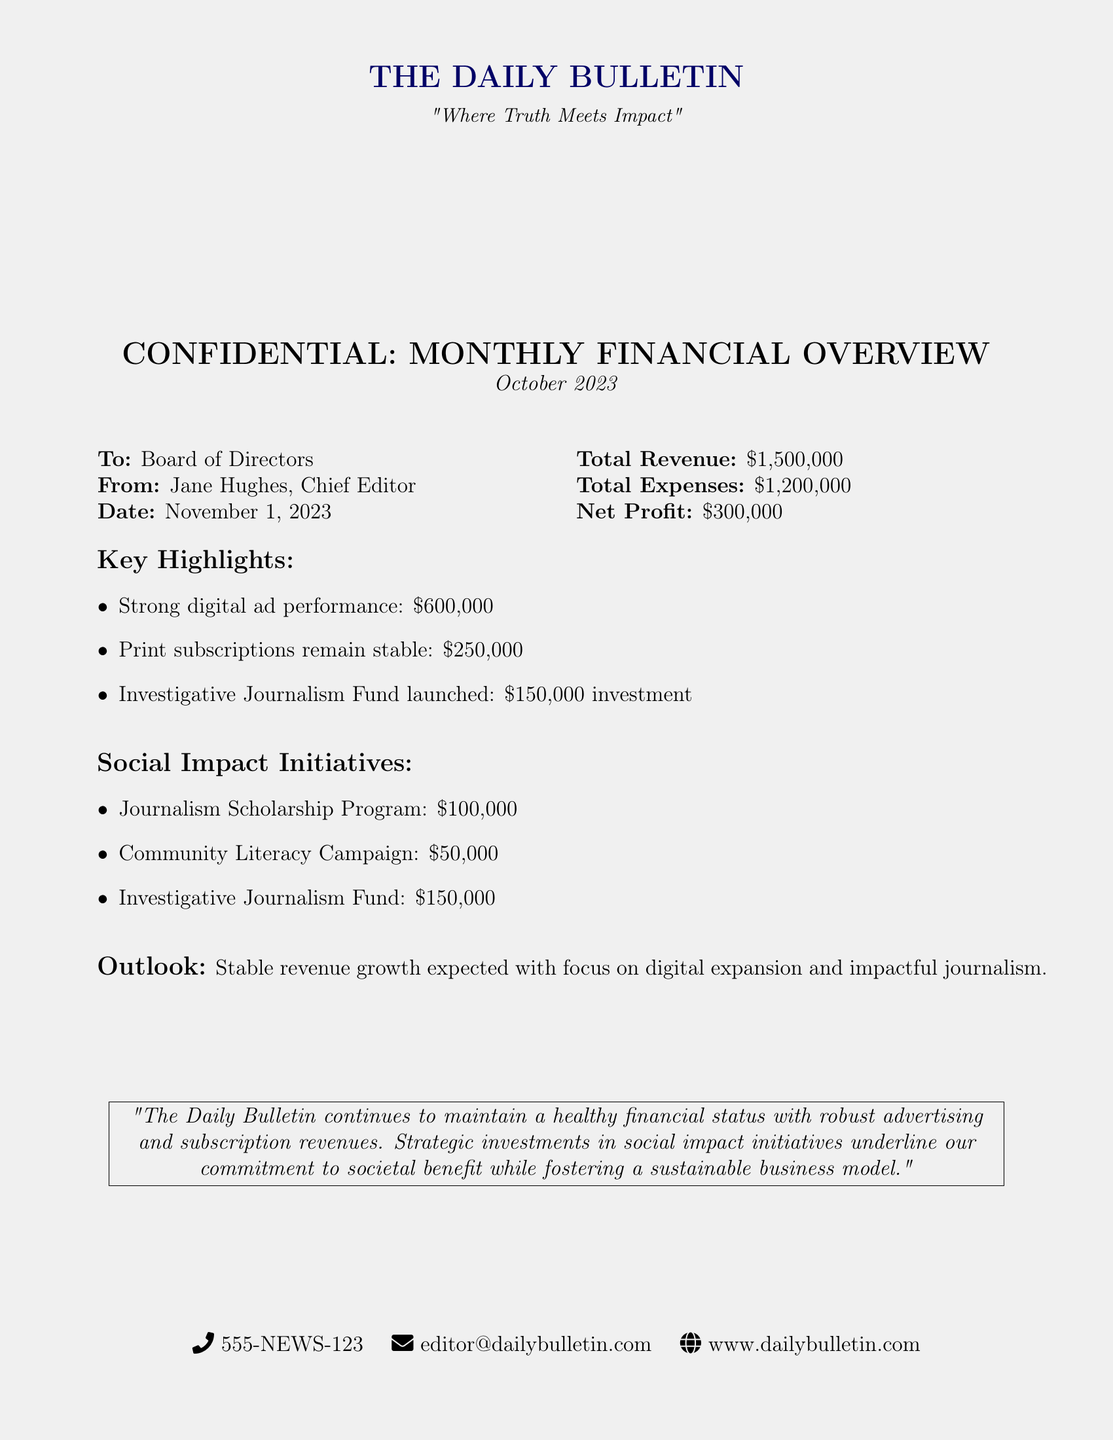what is the total revenue? The total revenue is explicitly stated as $1,500,000 in the document.
Answer: $1,500,000 who is the Chief Editor? The Chief Editor is identified in the document as Jane Hughes.
Answer: Jane Hughes what is the net profit? The net profit is calculated by subtracting total expenses from total revenue, which is $300,000.
Answer: $300,000 how much was invested in the Investigative Journalism Fund? The investment amount for the Investigative Journalism Fund is listed as $150,000.
Answer: $150,000 what is the total amount allocated for social impact initiatives? The total amount for social impact initiatives is the sum of all initiatives listed, which totals $300,000 ($100,000 + $50,000 + $150,000).
Answer: $300,000 what is the expectation for future revenue growth? The document states that stable revenue growth is expected, highlighting a focus on digital expansion.
Answer: Stable revenue growth what is the amount earned from digital ad performance? The document states that digital ad performance generated $600,000.
Answer: $600,000 how much is allocated for the Community Literacy Campaign? The amount allocated for the Community Literacy Campaign is indicated as $50,000 in the document.
Answer: $50,000 